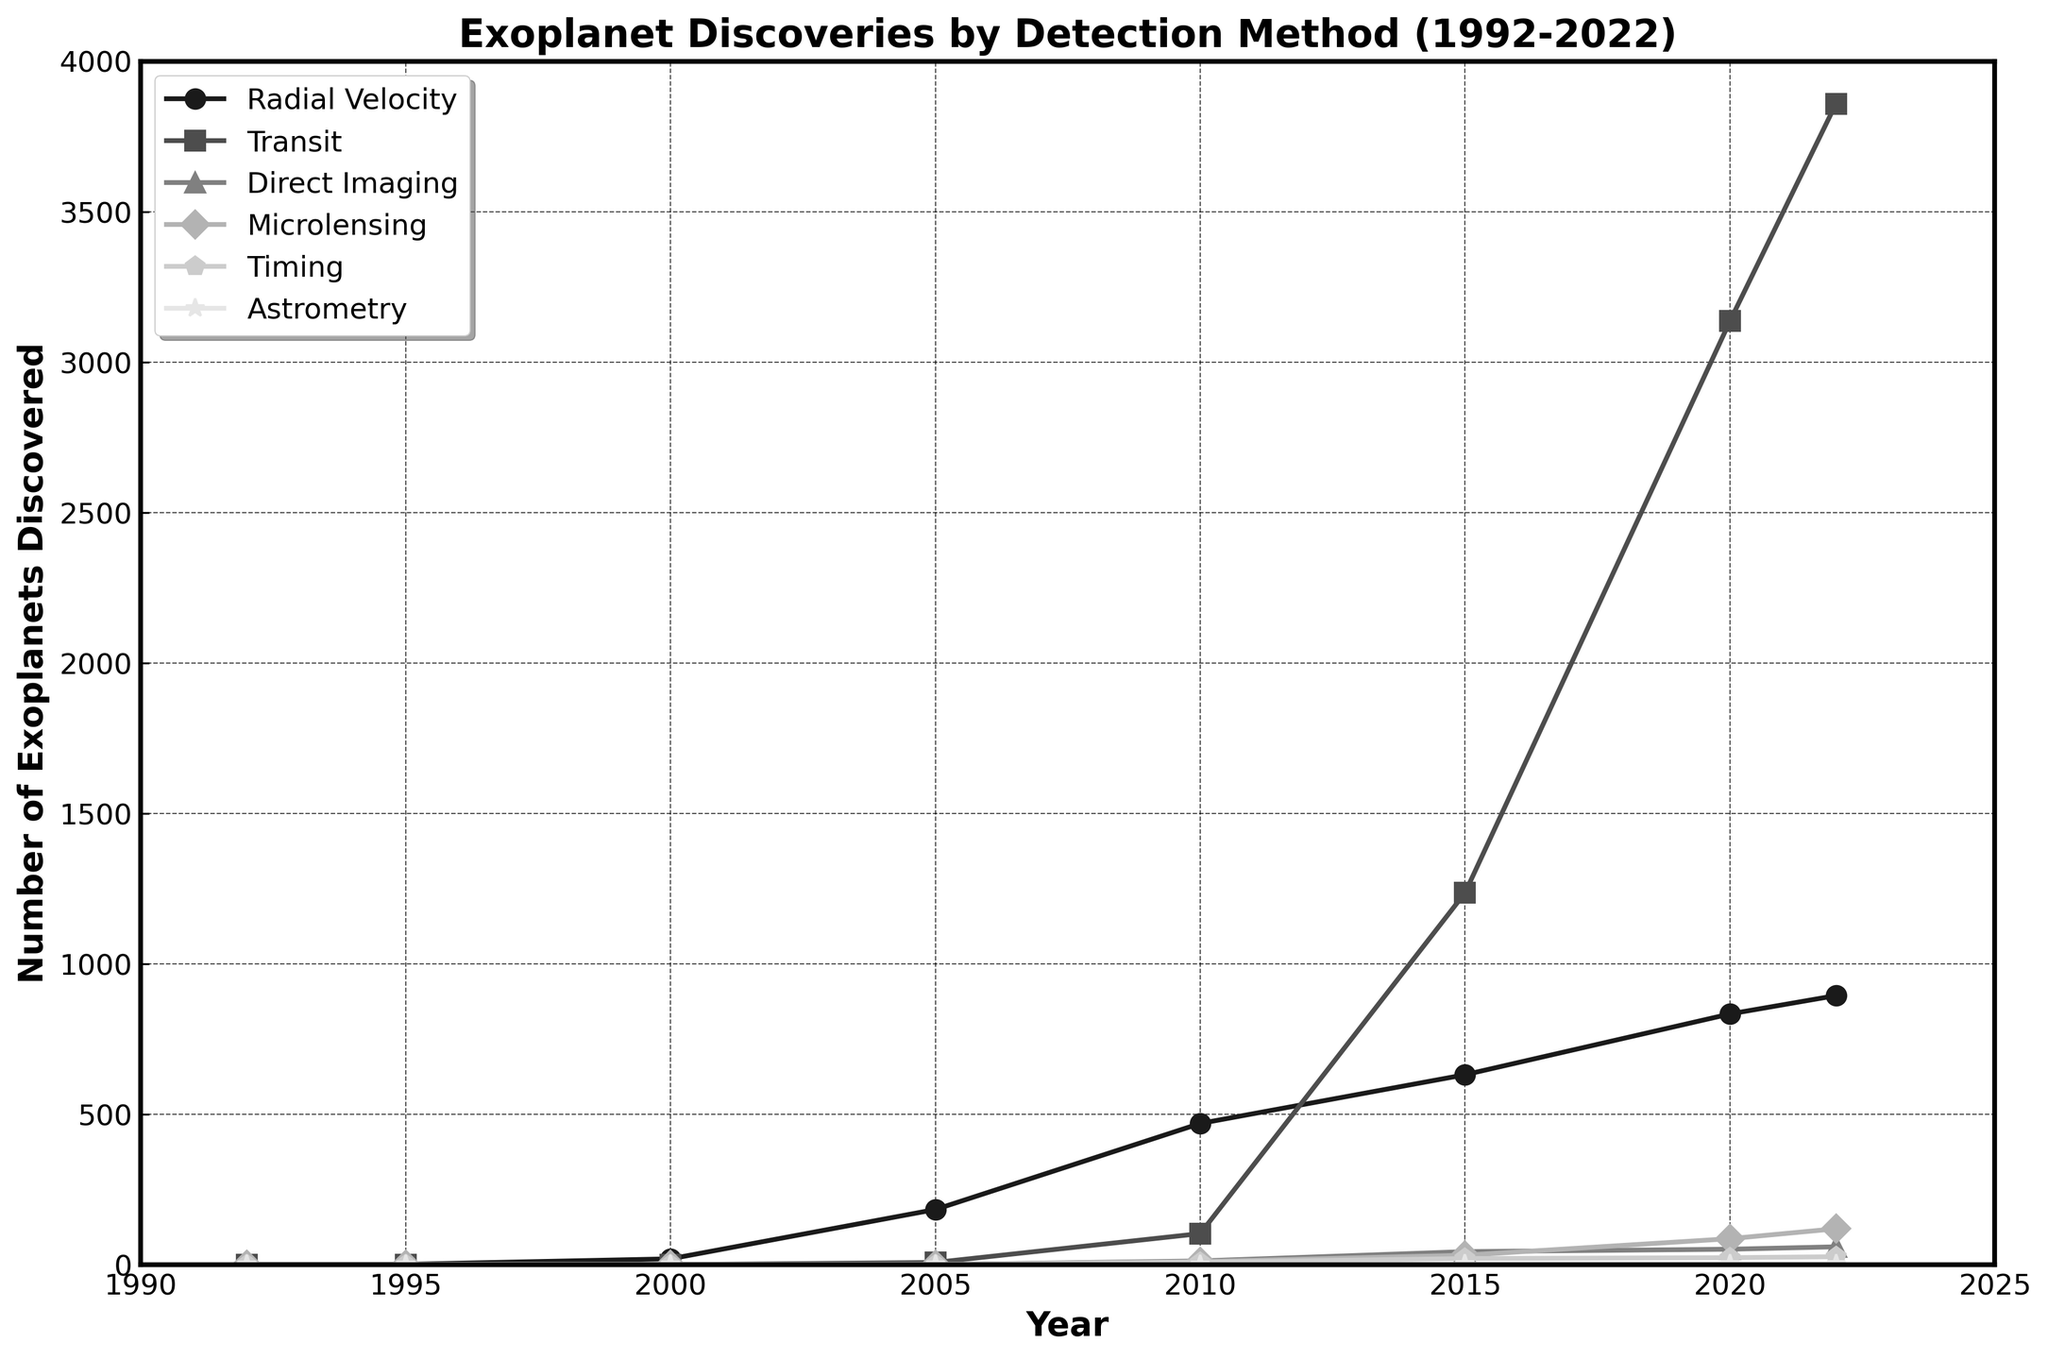What detection method discovered the most exoplanets in 2022? Examine the data series for each detection method in 2022. The 'Transit' method has the highest count of exoplanets discovered, reaching 3858.
Answer: Transit What is the total number of exoplanets discovered by the 'Microlensing' method from 2010 to 2022? Sum the values for the 'Microlensing' method from 2010 (10), 2015 (31), 2020 (86), and 2022 (119). 10 + 31 + 86 + 119 = 246.
Answer: 246 Which year saw the highest number of exoplanets discovered using the 'Transit' method? Look at the 'Transit' method series and identify the year 2022 as the highest point with 3858 exoplanets discovered.
Answer: 2022 Compared to the 'Microlensing' method, how many more exoplanets were discovered using the 'Direct Imaging' method in 2020? The 'Direct Imaging' method discovered 51 exoplanets in 2020, while the 'Microlensing' method discovered 86. Calculate the difference: 86 - 51 = 35.
Answer: 35 Which methods saw an increase in the number of exoplanets discovered from 2010 to 2022? Compare the values in 2010 with those in 2022 for each method:
- Radial Velocity: From 469 to 894 (Increase)
- Transit: From 103 to 3858 (Increase)
- Direct Imaging: From 12 to 59 (Increase)
- Microlensing: From 10 to 119 (Increase)
- Timing: From 8 to 26 (Increase)
- Astrometry: From 0 to 2 (Increase) All methods saw an increase.
Answer: All methods What is the difference in the number of exoplanets discovered using 'Radial Velocity' between 2000 and 2022? Subtract the number of exoplanets discovered using 'Radial Velocity' in 2000 (19) from the number in 2022 (894). 894 - 19 = 875.
Answer: 875 In which year did the 'Timing' method discover its highest number of exoplanets? Look at the highest value point in the 'Timing' series, which occurs in 2022 with 26 exoplanets.
Answer: 2022 What detection method saw the least increase in discovered exoplanets from 1992 to 2022? Compare the increase for each method from 1992 to 2022:
- Radial Velocity: 894 - 1 = 893
- Transit: 3858 - 0 = 3858
- Direct Imaging: 59 - 0 = 59
- Microlensing: 119 - 0 = 119
- Timing: 26 - 0 = 26
- Astrometry: 2 - 0 = 2 The 'Astrometry' method saw the least increase, with only 2 exoplanets discovered.
Answer: Astrometry 